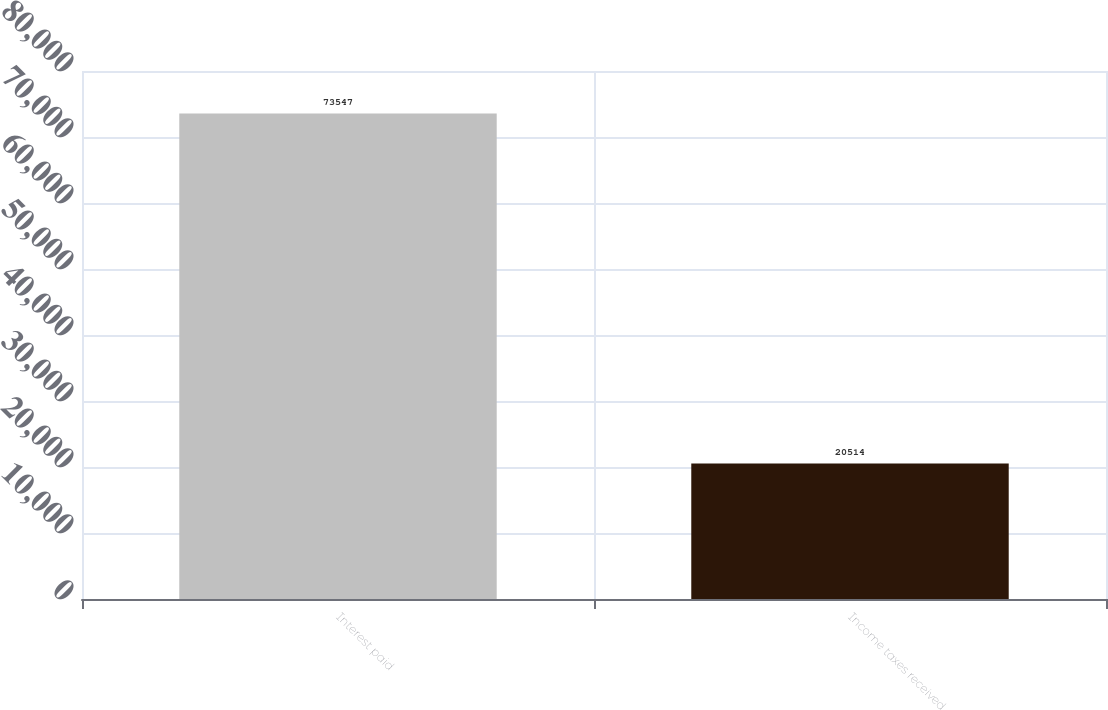Convert chart to OTSL. <chart><loc_0><loc_0><loc_500><loc_500><bar_chart><fcel>Interest paid<fcel>Income taxes received<nl><fcel>73547<fcel>20514<nl></chart> 